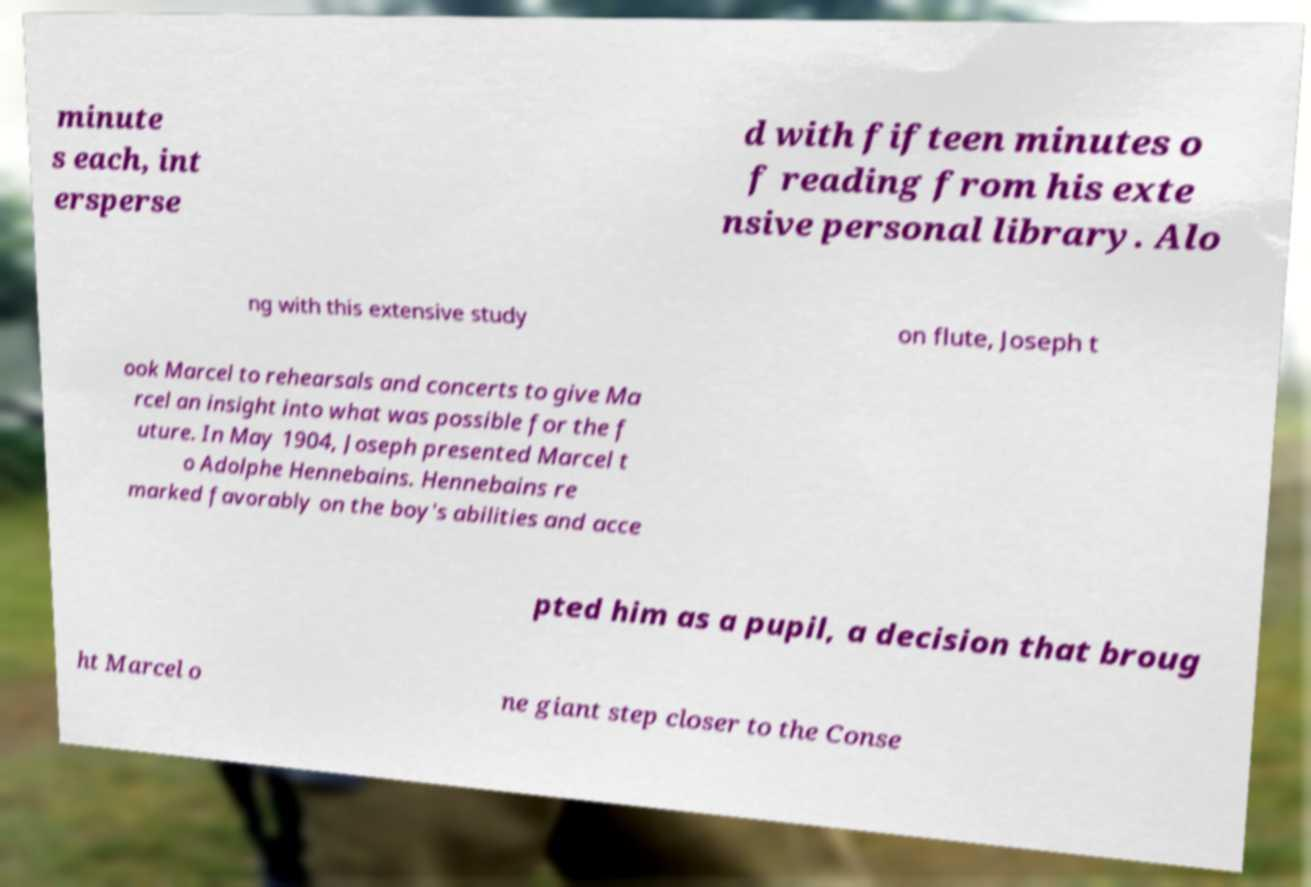Please identify and transcribe the text found in this image. minute s each, int ersperse d with fifteen minutes o f reading from his exte nsive personal library. Alo ng with this extensive study on flute, Joseph t ook Marcel to rehearsals and concerts to give Ma rcel an insight into what was possible for the f uture. In May 1904, Joseph presented Marcel t o Adolphe Hennebains. Hennebains re marked favorably on the boy's abilities and acce pted him as a pupil, a decision that broug ht Marcel o ne giant step closer to the Conse 